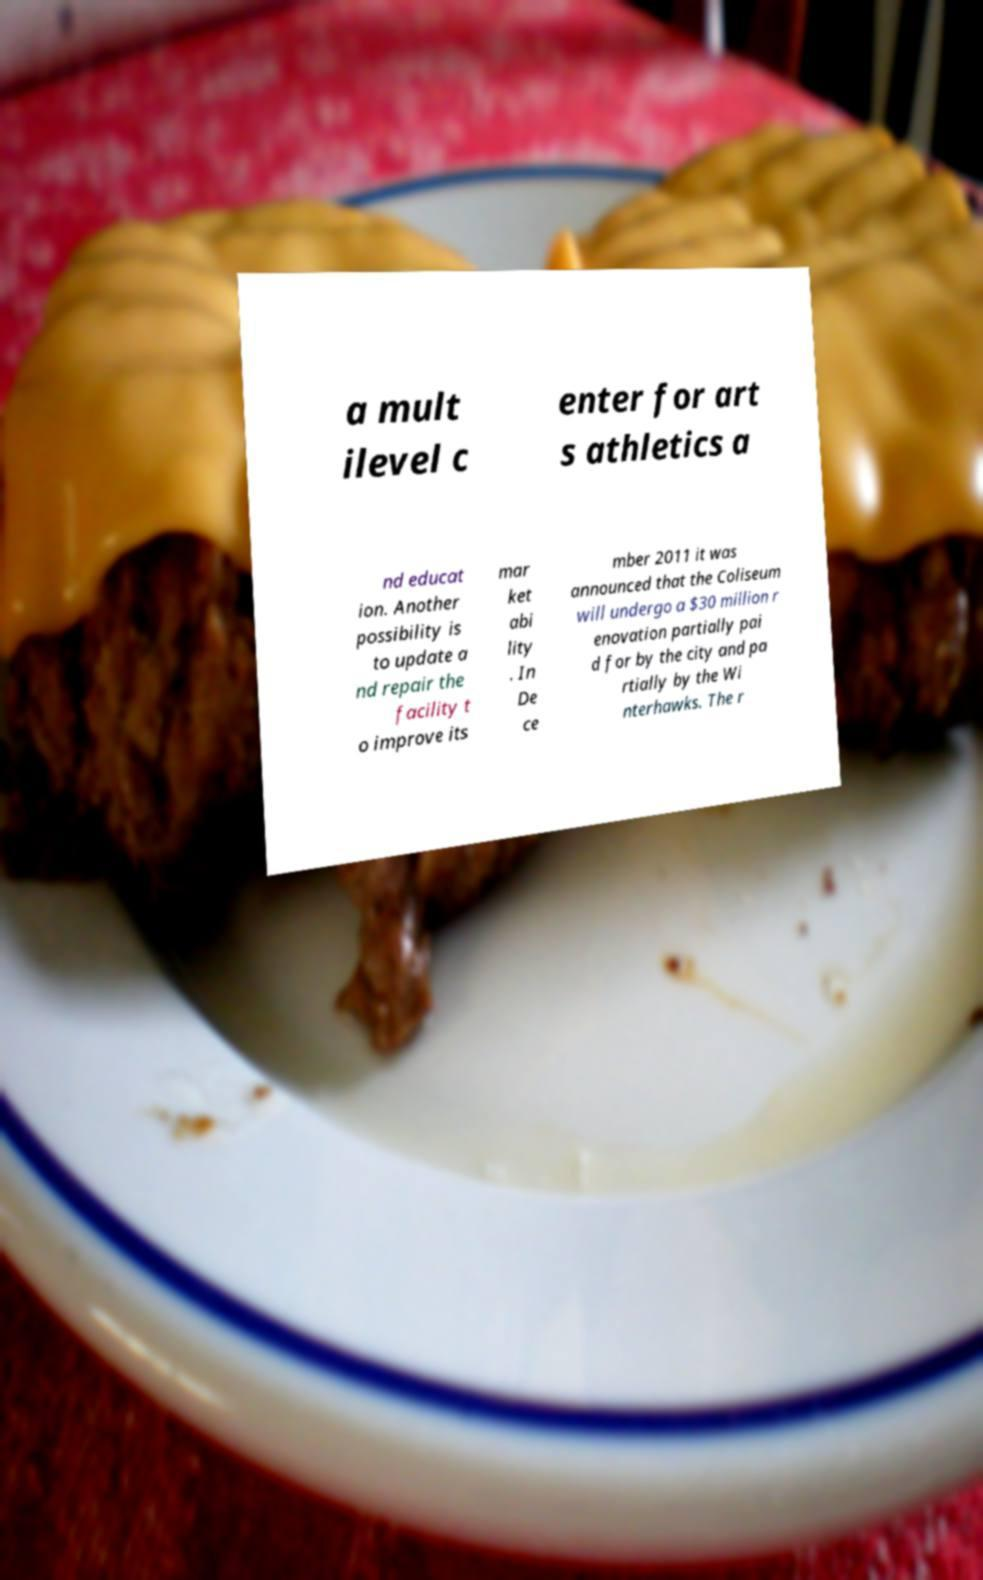What messages or text are displayed in this image? I need them in a readable, typed format. a mult ilevel c enter for art s athletics a nd educat ion. Another possibility is to update a nd repair the facility t o improve its mar ket abi lity . In De ce mber 2011 it was announced that the Coliseum will undergo a $30 million r enovation partially pai d for by the city and pa rtially by the Wi nterhawks. The r 